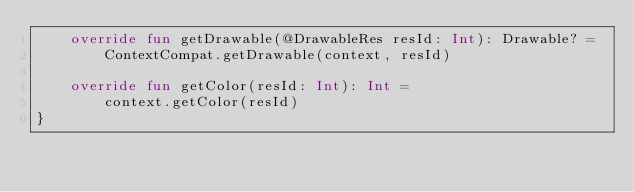Convert code to text. <code><loc_0><loc_0><loc_500><loc_500><_Kotlin_>    override fun getDrawable(@DrawableRes resId: Int): Drawable? =
        ContextCompat.getDrawable(context, resId)

    override fun getColor(resId: Int): Int =
        context.getColor(resId)
}
</code> 